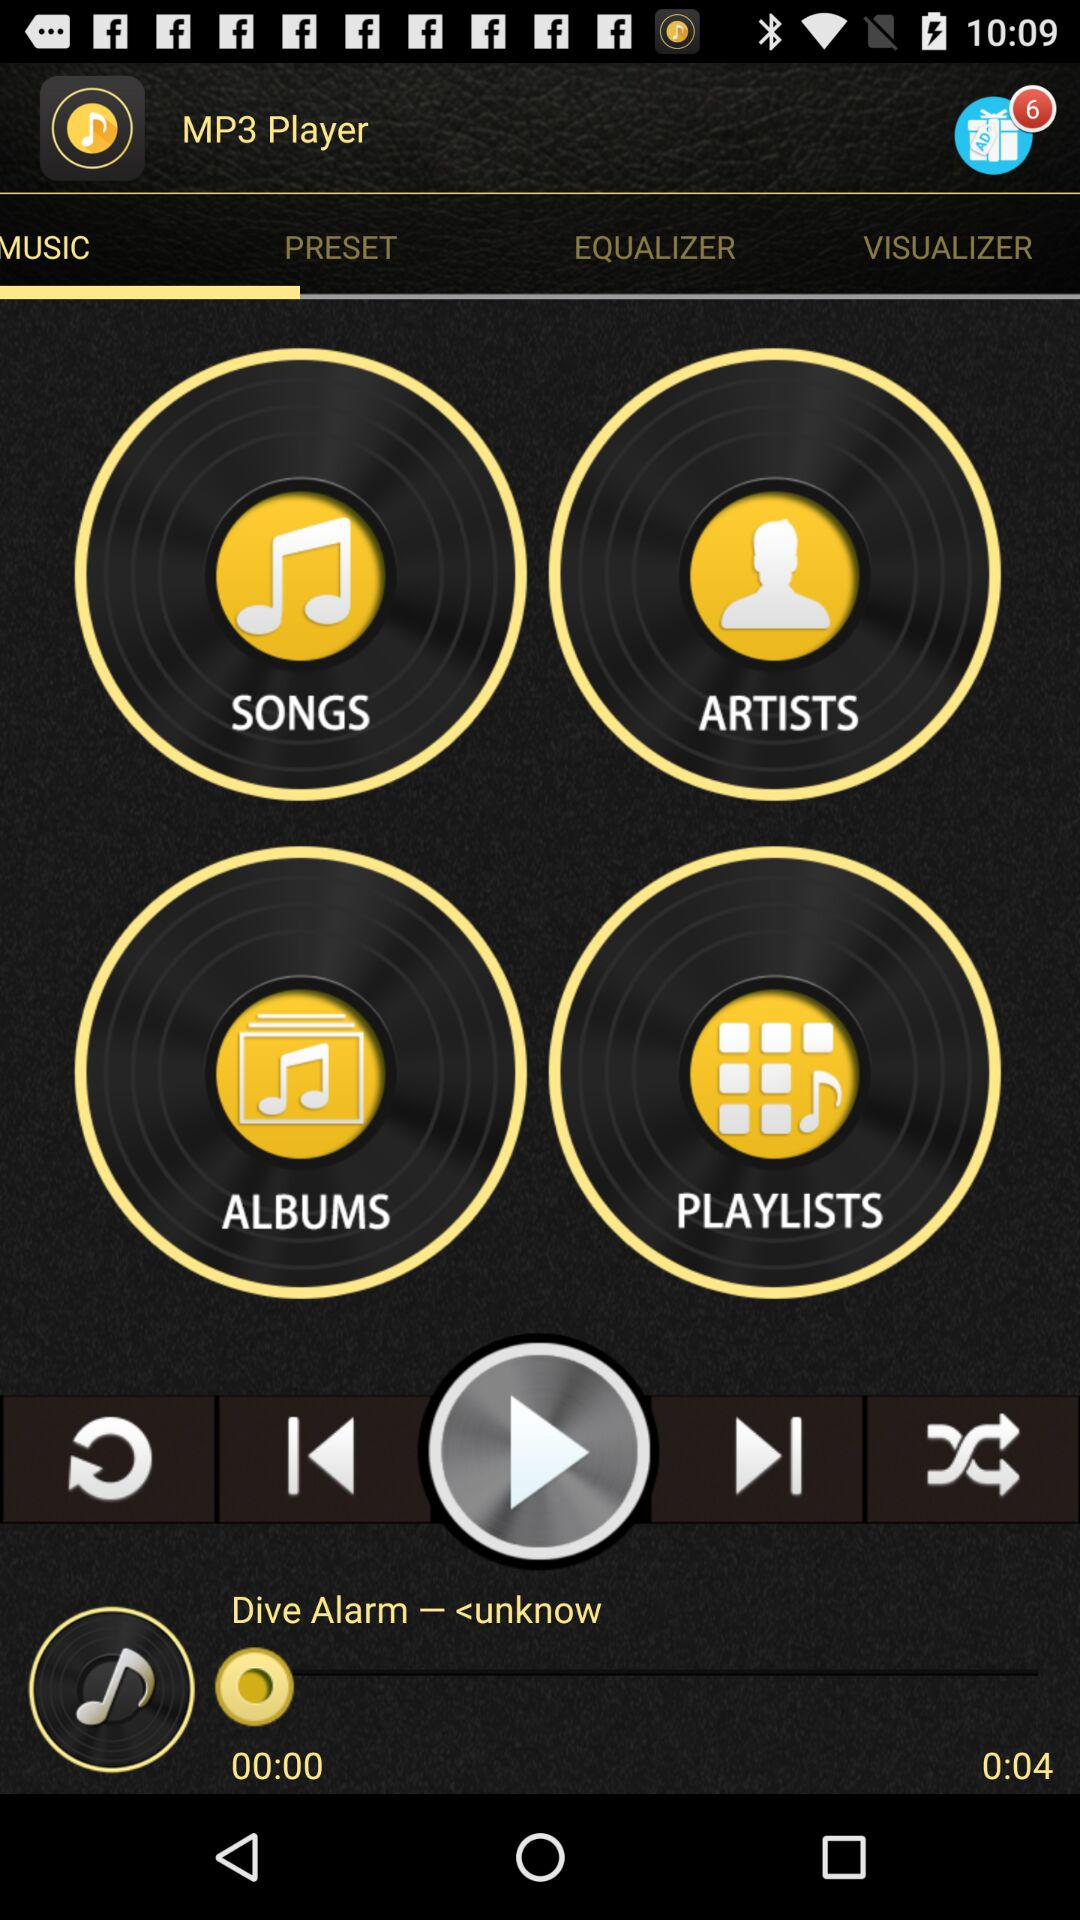How many seconds has the song been playing for?
Answer the question using a single word or phrase. 4 